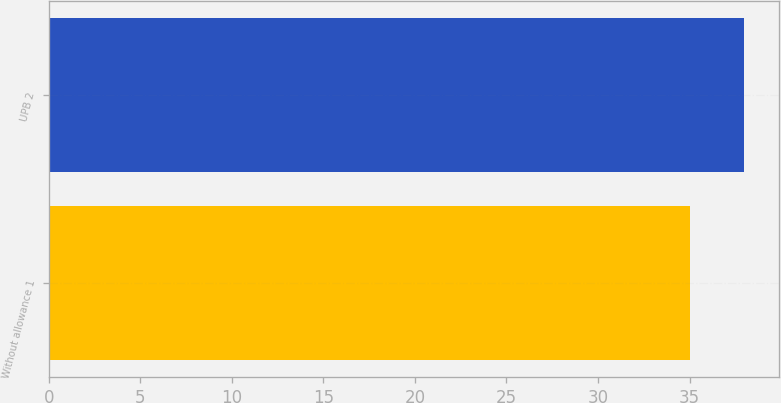<chart> <loc_0><loc_0><loc_500><loc_500><bar_chart><fcel>Without allowance 1<fcel>UPB 2<nl><fcel>35<fcel>38<nl></chart> 